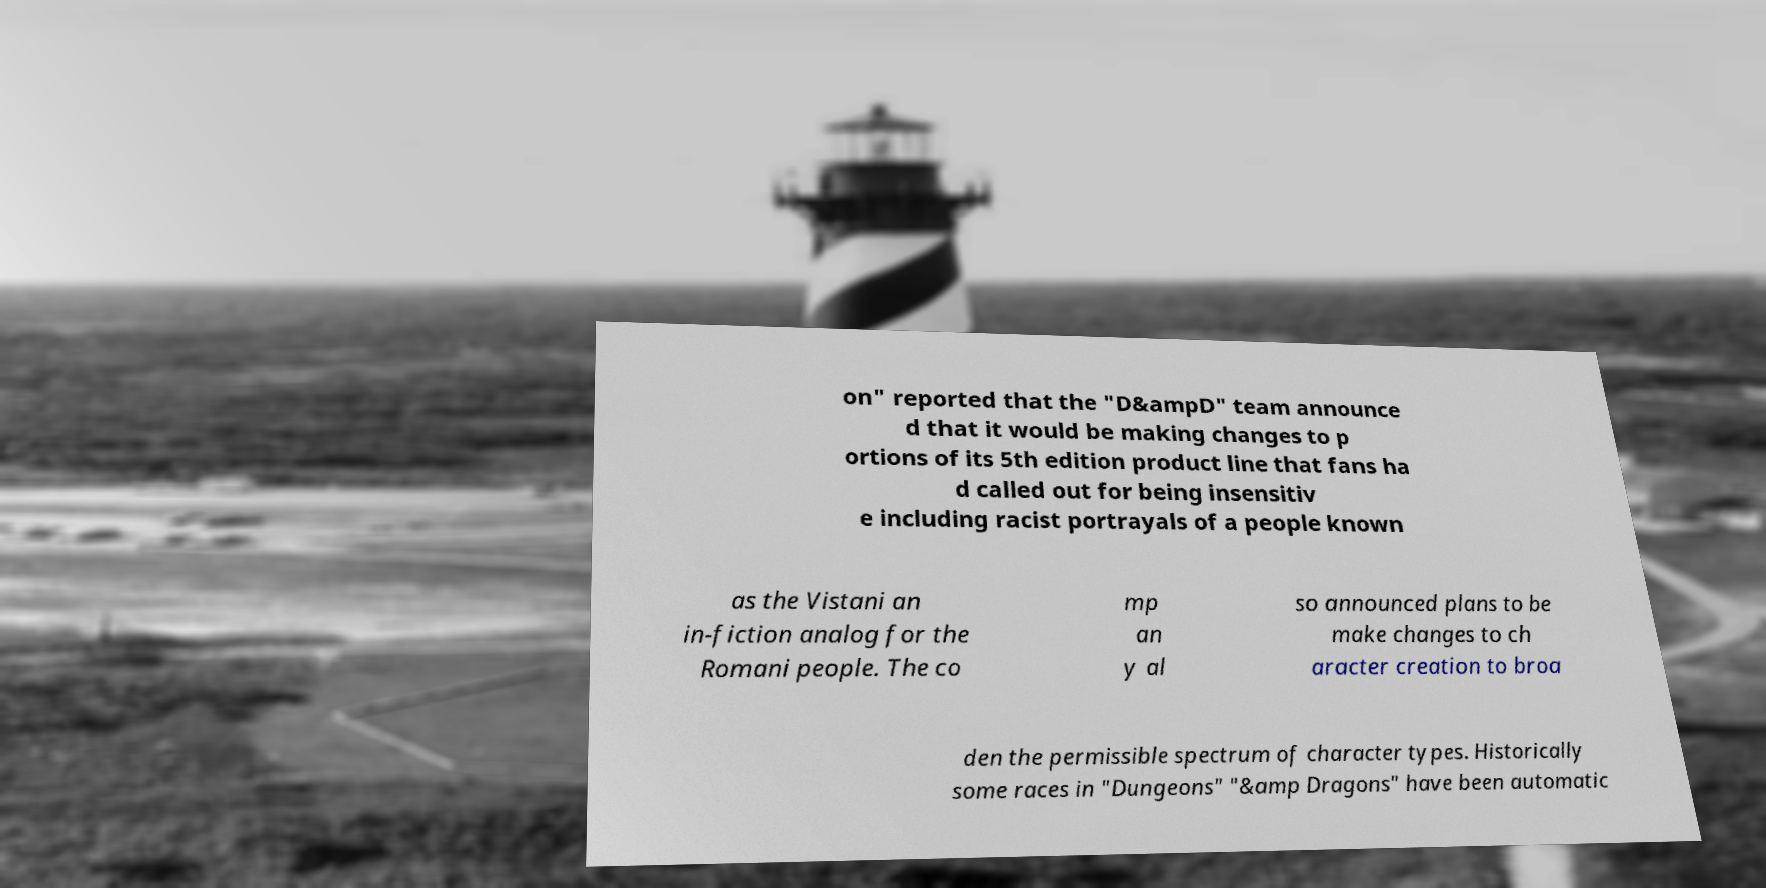Could you assist in decoding the text presented in this image and type it out clearly? on" reported that the "D&ampD" team announce d that it would be making changes to p ortions of its 5th edition product line that fans ha d called out for being insensitiv e including racist portrayals of a people known as the Vistani an in-fiction analog for the Romani people. The co mp an y al so announced plans to be make changes to ch aracter creation to broa den the permissible spectrum of character types. Historically some races in "Dungeons" "&amp Dragons" have been automatic 